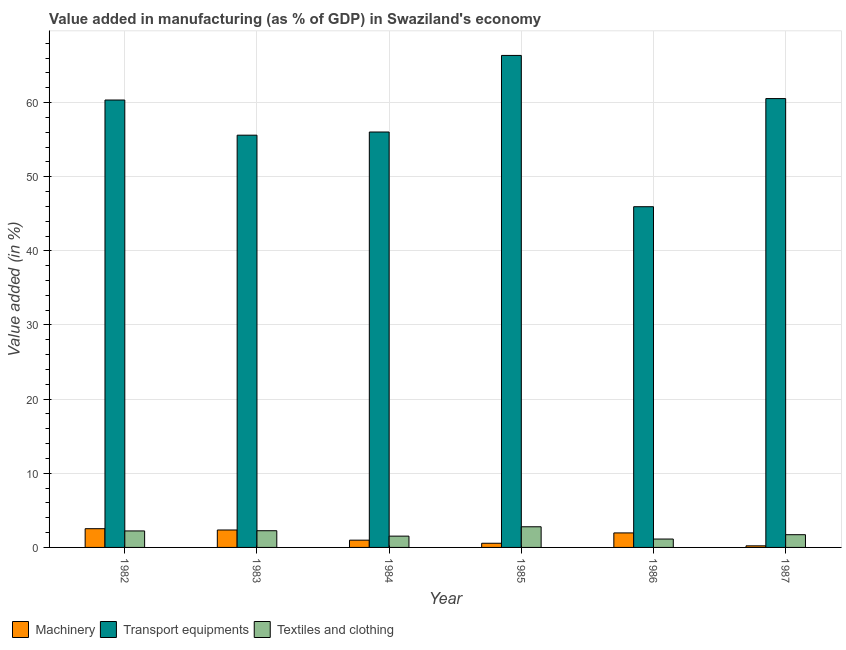How many different coloured bars are there?
Your response must be concise. 3. Are the number of bars on each tick of the X-axis equal?
Your response must be concise. Yes. How many bars are there on the 6th tick from the right?
Your answer should be very brief. 3. In how many cases, is the number of bars for a given year not equal to the number of legend labels?
Offer a very short reply. 0. What is the value added in manufacturing machinery in 1984?
Your answer should be very brief. 0.98. Across all years, what is the maximum value added in manufacturing transport equipments?
Your answer should be very brief. 66.36. Across all years, what is the minimum value added in manufacturing textile and clothing?
Provide a succinct answer. 1.13. In which year was the value added in manufacturing transport equipments maximum?
Provide a short and direct response. 1985. In which year was the value added in manufacturing transport equipments minimum?
Your response must be concise. 1986. What is the total value added in manufacturing transport equipments in the graph?
Your response must be concise. 344.82. What is the difference between the value added in manufacturing textile and clothing in 1983 and that in 1985?
Provide a succinct answer. -0.53. What is the difference between the value added in manufacturing textile and clothing in 1982 and the value added in manufacturing machinery in 1983?
Keep it short and to the point. -0.03. What is the average value added in manufacturing textile and clothing per year?
Offer a very short reply. 1.94. In the year 1984, what is the difference between the value added in manufacturing machinery and value added in manufacturing textile and clothing?
Give a very brief answer. 0. What is the ratio of the value added in manufacturing machinery in 1985 to that in 1987?
Make the answer very short. 2.62. Is the value added in manufacturing machinery in 1982 less than that in 1984?
Provide a short and direct response. No. What is the difference between the highest and the second highest value added in manufacturing textile and clothing?
Ensure brevity in your answer.  0.53. What is the difference between the highest and the lowest value added in manufacturing textile and clothing?
Provide a short and direct response. 1.65. In how many years, is the value added in manufacturing textile and clothing greater than the average value added in manufacturing textile and clothing taken over all years?
Your answer should be very brief. 3. Is the sum of the value added in manufacturing transport equipments in 1982 and 1984 greater than the maximum value added in manufacturing textile and clothing across all years?
Give a very brief answer. Yes. What does the 1st bar from the left in 1985 represents?
Provide a succinct answer. Machinery. What does the 3rd bar from the right in 1985 represents?
Your answer should be very brief. Machinery. Is it the case that in every year, the sum of the value added in manufacturing machinery and value added in manufacturing transport equipments is greater than the value added in manufacturing textile and clothing?
Make the answer very short. Yes. Are all the bars in the graph horizontal?
Make the answer very short. No. Where does the legend appear in the graph?
Provide a short and direct response. Bottom left. How many legend labels are there?
Your answer should be compact. 3. What is the title of the graph?
Your answer should be very brief. Value added in manufacturing (as % of GDP) in Swaziland's economy. What is the label or title of the X-axis?
Your response must be concise. Year. What is the label or title of the Y-axis?
Provide a succinct answer. Value added (in %). What is the Value added (in %) of Machinery in 1982?
Make the answer very short. 2.53. What is the Value added (in %) in Transport equipments in 1982?
Keep it short and to the point. 60.34. What is the Value added (in %) in Textiles and clothing in 1982?
Provide a succinct answer. 2.23. What is the Value added (in %) in Machinery in 1983?
Offer a terse response. 2.35. What is the Value added (in %) of Transport equipments in 1983?
Provide a succinct answer. 55.6. What is the Value added (in %) of Textiles and clothing in 1983?
Your answer should be compact. 2.25. What is the Value added (in %) in Machinery in 1984?
Your answer should be very brief. 0.98. What is the Value added (in %) in Transport equipments in 1984?
Provide a succinct answer. 56.03. What is the Value added (in %) in Textiles and clothing in 1984?
Your response must be concise. 1.52. What is the Value added (in %) in Machinery in 1985?
Provide a short and direct response. 0.56. What is the Value added (in %) in Transport equipments in 1985?
Give a very brief answer. 66.36. What is the Value added (in %) of Textiles and clothing in 1985?
Give a very brief answer. 2.79. What is the Value added (in %) of Machinery in 1986?
Your answer should be very brief. 1.96. What is the Value added (in %) in Transport equipments in 1986?
Offer a terse response. 45.95. What is the Value added (in %) in Textiles and clothing in 1986?
Offer a very short reply. 1.13. What is the Value added (in %) in Machinery in 1987?
Your answer should be compact. 0.22. What is the Value added (in %) in Transport equipments in 1987?
Your response must be concise. 60.54. What is the Value added (in %) in Textiles and clothing in 1987?
Give a very brief answer. 1.72. Across all years, what is the maximum Value added (in %) in Machinery?
Give a very brief answer. 2.53. Across all years, what is the maximum Value added (in %) in Transport equipments?
Ensure brevity in your answer.  66.36. Across all years, what is the maximum Value added (in %) of Textiles and clothing?
Your answer should be very brief. 2.79. Across all years, what is the minimum Value added (in %) of Machinery?
Your response must be concise. 0.22. Across all years, what is the minimum Value added (in %) in Transport equipments?
Your answer should be very brief. 45.95. Across all years, what is the minimum Value added (in %) in Textiles and clothing?
Keep it short and to the point. 1.13. What is the total Value added (in %) in Machinery in the graph?
Your response must be concise. 8.59. What is the total Value added (in %) in Transport equipments in the graph?
Your answer should be compact. 344.82. What is the total Value added (in %) of Textiles and clothing in the graph?
Keep it short and to the point. 11.64. What is the difference between the Value added (in %) of Machinery in 1982 and that in 1983?
Ensure brevity in your answer.  0.17. What is the difference between the Value added (in %) in Transport equipments in 1982 and that in 1983?
Make the answer very short. 4.74. What is the difference between the Value added (in %) in Textiles and clothing in 1982 and that in 1983?
Keep it short and to the point. -0.03. What is the difference between the Value added (in %) in Machinery in 1982 and that in 1984?
Your response must be concise. 1.55. What is the difference between the Value added (in %) of Transport equipments in 1982 and that in 1984?
Your answer should be very brief. 4.31. What is the difference between the Value added (in %) in Textiles and clothing in 1982 and that in 1984?
Your answer should be compact. 0.7. What is the difference between the Value added (in %) of Machinery in 1982 and that in 1985?
Provide a short and direct response. 1.96. What is the difference between the Value added (in %) in Transport equipments in 1982 and that in 1985?
Ensure brevity in your answer.  -6.01. What is the difference between the Value added (in %) of Textiles and clothing in 1982 and that in 1985?
Provide a succinct answer. -0.56. What is the difference between the Value added (in %) in Machinery in 1982 and that in 1986?
Keep it short and to the point. 0.57. What is the difference between the Value added (in %) in Transport equipments in 1982 and that in 1986?
Offer a very short reply. 14.39. What is the difference between the Value added (in %) of Textiles and clothing in 1982 and that in 1986?
Your answer should be compact. 1.09. What is the difference between the Value added (in %) in Machinery in 1982 and that in 1987?
Your answer should be compact. 2.31. What is the difference between the Value added (in %) in Transport equipments in 1982 and that in 1987?
Offer a terse response. -0.19. What is the difference between the Value added (in %) in Textiles and clothing in 1982 and that in 1987?
Offer a terse response. 0.51. What is the difference between the Value added (in %) of Machinery in 1983 and that in 1984?
Offer a very short reply. 1.37. What is the difference between the Value added (in %) in Transport equipments in 1983 and that in 1984?
Ensure brevity in your answer.  -0.43. What is the difference between the Value added (in %) of Textiles and clothing in 1983 and that in 1984?
Offer a very short reply. 0.73. What is the difference between the Value added (in %) of Machinery in 1983 and that in 1985?
Provide a succinct answer. 1.79. What is the difference between the Value added (in %) in Transport equipments in 1983 and that in 1985?
Your answer should be compact. -10.76. What is the difference between the Value added (in %) in Textiles and clothing in 1983 and that in 1985?
Provide a short and direct response. -0.53. What is the difference between the Value added (in %) of Machinery in 1983 and that in 1986?
Give a very brief answer. 0.39. What is the difference between the Value added (in %) in Transport equipments in 1983 and that in 1986?
Your response must be concise. 9.65. What is the difference between the Value added (in %) in Textiles and clothing in 1983 and that in 1986?
Offer a very short reply. 1.12. What is the difference between the Value added (in %) in Machinery in 1983 and that in 1987?
Provide a succinct answer. 2.14. What is the difference between the Value added (in %) in Transport equipments in 1983 and that in 1987?
Provide a short and direct response. -4.94. What is the difference between the Value added (in %) of Textiles and clothing in 1983 and that in 1987?
Provide a short and direct response. 0.54. What is the difference between the Value added (in %) of Machinery in 1984 and that in 1985?
Your response must be concise. 0.42. What is the difference between the Value added (in %) of Transport equipments in 1984 and that in 1985?
Your response must be concise. -10.33. What is the difference between the Value added (in %) of Textiles and clothing in 1984 and that in 1985?
Offer a terse response. -1.26. What is the difference between the Value added (in %) of Machinery in 1984 and that in 1986?
Your response must be concise. -0.98. What is the difference between the Value added (in %) of Transport equipments in 1984 and that in 1986?
Your response must be concise. 10.07. What is the difference between the Value added (in %) in Textiles and clothing in 1984 and that in 1986?
Your answer should be very brief. 0.39. What is the difference between the Value added (in %) in Machinery in 1984 and that in 1987?
Offer a very short reply. 0.76. What is the difference between the Value added (in %) in Transport equipments in 1984 and that in 1987?
Provide a short and direct response. -4.51. What is the difference between the Value added (in %) in Textiles and clothing in 1984 and that in 1987?
Your answer should be compact. -0.19. What is the difference between the Value added (in %) of Machinery in 1985 and that in 1986?
Offer a very short reply. -1.39. What is the difference between the Value added (in %) of Transport equipments in 1985 and that in 1986?
Provide a succinct answer. 20.4. What is the difference between the Value added (in %) in Textiles and clothing in 1985 and that in 1986?
Ensure brevity in your answer.  1.65. What is the difference between the Value added (in %) in Machinery in 1985 and that in 1987?
Your response must be concise. 0.35. What is the difference between the Value added (in %) in Transport equipments in 1985 and that in 1987?
Your answer should be very brief. 5.82. What is the difference between the Value added (in %) of Textiles and clothing in 1985 and that in 1987?
Your answer should be compact. 1.07. What is the difference between the Value added (in %) in Machinery in 1986 and that in 1987?
Provide a succinct answer. 1.74. What is the difference between the Value added (in %) in Transport equipments in 1986 and that in 1987?
Your answer should be compact. -14.58. What is the difference between the Value added (in %) of Textiles and clothing in 1986 and that in 1987?
Provide a succinct answer. -0.58. What is the difference between the Value added (in %) of Machinery in 1982 and the Value added (in %) of Transport equipments in 1983?
Provide a short and direct response. -53.07. What is the difference between the Value added (in %) in Machinery in 1982 and the Value added (in %) in Textiles and clothing in 1983?
Your answer should be compact. 0.27. What is the difference between the Value added (in %) of Transport equipments in 1982 and the Value added (in %) of Textiles and clothing in 1983?
Offer a terse response. 58.09. What is the difference between the Value added (in %) in Machinery in 1982 and the Value added (in %) in Transport equipments in 1984?
Offer a terse response. -53.5. What is the difference between the Value added (in %) in Machinery in 1982 and the Value added (in %) in Textiles and clothing in 1984?
Offer a terse response. 1. What is the difference between the Value added (in %) of Transport equipments in 1982 and the Value added (in %) of Textiles and clothing in 1984?
Your answer should be very brief. 58.82. What is the difference between the Value added (in %) of Machinery in 1982 and the Value added (in %) of Transport equipments in 1985?
Your answer should be very brief. -63.83. What is the difference between the Value added (in %) in Machinery in 1982 and the Value added (in %) in Textiles and clothing in 1985?
Offer a very short reply. -0.26. What is the difference between the Value added (in %) of Transport equipments in 1982 and the Value added (in %) of Textiles and clothing in 1985?
Make the answer very short. 57.56. What is the difference between the Value added (in %) of Machinery in 1982 and the Value added (in %) of Transport equipments in 1986?
Offer a very short reply. -43.43. What is the difference between the Value added (in %) of Machinery in 1982 and the Value added (in %) of Textiles and clothing in 1986?
Ensure brevity in your answer.  1.39. What is the difference between the Value added (in %) in Transport equipments in 1982 and the Value added (in %) in Textiles and clothing in 1986?
Provide a short and direct response. 59.21. What is the difference between the Value added (in %) of Machinery in 1982 and the Value added (in %) of Transport equipments in 1987?
Provide a succinct answer. -58.01. What is the difference between the Value added (in %) in Machinery in 1982 and the Value added (in %) in Textiles and clothing in 1987?
Offer a terse response. 0.81. What is the difference between the Value added (in %) in Transport equipments in 1982 and the Value added (in %) in Textiles and clothing in 1987?
Your response must be concise. 58.63. What is the difference between the Value added (in %) in Machinery in 1983 and the Value added (in %) in Transport equipments in 1984?
Provide a short and direct response. -53.68. What is the difference between the Value added (in %) in Machinery in 1983 and the Value added (in %) in Textiles and clothing in 1984?
Ensure brevity in your answer.  0.83. What is the difference between the Value added (in %) of Transport equipments in 1983 and the Value added (in %) of Textiles and clothing in 1984?
Your answer should be compact. 54.08. What is the difference between the Value added (in %) of Machinery in 1983 and the Value added (in %) of Transport equipments in 1985?
Offer a very short reply. -64.01. What is the difference between the Value added (in %) in Machinery in 1983 and the Value added (in %) in Textiles and clothing in 1985?
Your answer should be very brief. -0.43. What is the difference between the Value added (in %) in Transport equipments in 1983 and the Value added (in %) in Textiles and clothing in 1985?
Offer a very short reply. 52.81. What is the difference between the Value added (in %) of Machinery in 1983 and the Value added (in %) of Transport equipments in 1986?
Make the answer very short. -43.6. What is the difference between the Value added (in %) of Machinery in 1983 and the Value added (in %) of Textiles and clothing in 1986?
Ensure brevity in your answer.  1.22. What is the difference between the Value added (in %) of Transport equipments in 1983 and the Value added (in %) of Textiles and clothing in 1986?
Your answer should be compact. 54.47. What is the difference between the Value added (in %) of Machinery in 1983 and the Value added (in %) of Transport equipments in 1987?
Ensure brevity in your answer.  -58.19. What is the difference between the Value added (in %) of Machinery in 1983 and the Value added (in %) of Textiles and clothing in 1987?
Make the answer very short. 0.63. What is the difference between the Value added (in %) of Transport equipments in 1983 and the Value added (in %) of Textiles and clothing in 1987?
Give a very brief answer. 53.88. What is the difference between the Value added (in %) in Machinery in 1984 and the Value added (in %) in Transport equipments in 1985?
Keep it short and to the point. -65.38. What is the difference between the Value added (in %) of Machinery in 1984 and the Value added (in %) of Textiles and clothing in 1985?
Offer a terse response. -1.81. What is the difference between the Value added (in %) in Transport equipments in 1984 and the Value added (in %) in Textiles and clothing in 1985?
Keep it short and to the point. 53.24. What is the difference between the Value added (in %) in Machinery in 1984 and the Value added (in %) in Transport equipments in 1986?
Give a very brief answer. -44.97. What is the difference between the Value added (in %) of Machinery in 1984 and the Value added (in %) of Textiles and clothing in 1986?
Keep it short and to the point. -0.15. What is the difference between the Value added (in %) of Transport equipments in 1984 and the Value added (in %) of Textiles and clothing in 1986?
Your response must be concise. 54.9. What is the difference between the Value added (in %) of Machinery in 1984 and the Value added (in %) of Transport equipments in 1987?
Offer a very short reply. -59.56. What is the difference between the Value added (in %) in Machinery in 1984 and the Value added (in %) in Textiles and clothing in 1987?
Your answer should be compact. -0.74. What is the difference between the Value added (in %) in Transport equipments in 1984 and the Value added (in %) in Textiles and clothing in 1987?
Keep it short and to the point. 54.31. What is the difference between the Value added (in %) of Machinery in 1985 and the Value added (in %) of Transport equipments in 1986?
Ensure brevity in your answer.  -45.39. What is the difference between the Value added (in %) in Machinery in 1985 and the Value added (in %) in Textiles and clothing in 1986?
Give a very brief answer. -0.57. What is the difference between the Value added (in %) in Transport equipments in 1985 and the Value added (in %) in Textiles and clothing in 1986?
Offer a terse response. 65.23. What is the difference between the Value added (in %) of Machinery in 1985 and the Value added (in %) of Transport equipments in 1987?
Offer a terse response. -59.97. What is the difference between the Value added (in %) in Machinery in 1985 and the Value added (in %) in Textiles and clothing in 1987?
Your answer should be very brief. -1.15. What is the difference between the Value added (in %) in Transport equipments in 1985 and the Value added (in %) in Textiles and clothing in 1987?
Offer a terse response. 64.64. What is the difference between the Value added (in %) in Machinery in 1986 and the Value added (in %) in Transport equipments in 1987?
Offer a terse response. -58.58. What is the difference between the Value added (in %) in Machinery in 1986 and the Value added (in %) in Textiles and clothing in 1987?
Your response must be concise. 0.24. What is the difference between the Value added (in %) in Transport equipments in 1986 and the Value added (in %) in Textiles and clothing in 1987?
Keep it short and to the point. 44.24. What is the average Value added (in %) of Machinery per year?
Your response must be concise. 1.43. What is the average Value added (in %) in Transport equipments per year?
Provide a short and direct response. 57.47. What is the average Value added (in %) of Textiles and clothing per year?
Your answer should be very brief. 1.94. In the year 1982, what is the difference between the Value added (in %) of Machinery and Value added (in %) of Transport equipments?
Ensure brevity in your answer.  -57.82. In the year 1982, what is the difference between the Value added (in %) in Transport equipments and Value added (in %) in Textiles and clothing?
Your response must be concise. 58.12. In the year 1983, what is the difference between the Value added (in %) of Machinery and Value added (in %) of Transport equipments?
Give a very brief answer. -53.25. In the year 1983, what is the difference between the Value added (in %) of Machinery and Value added (in %) of Textiles and clothing?
Your response must be concise. 0.1. In the year 1983, what is the difference between the Value added (in %) of Transport equipments and Value added (in %) of Textiles and clothing?
Offer a very short reply. 53.35. In the year 1984, what is the difference between the Value added (in %) of Machinery and Value added (in %) of Transport equipments?
Keep it short and to the point. -55.05. In the year 1984, what is the difference between the Value added (in %) in Machinery and Value added (in %) in Textiles and clothing?
Offer a very short reply. -0.54. In the year 1984, what is the difference between the Value added (in %) of Transport equipments and Value added (in %) of Textiles and clothing?
Provide a short and direct response. 54.5. In the year 1985, what is the difference between the Value added (in %) of Machinery and Value added (in %) of Transport equipments?
Give a very brief answer. -65.79. In the year 1985, what is the difference between the Value added (in %) of Machinery and Value added (in %) of Textiles and clothing?
Give a very brief answer. -2.22. In the year 1985, what is the difference between the Value added (in %) of Transport equipments and Value added (in %) of Textiles and clothing?
Offer a very short reply. 63.57. In the year 1986, what is the difference between the Value added (in %) of Machinery and Value added (in %) of Transport equipments?
Your answer should be compact. -44. In the year 1986, what is the difference between the Value added (in %) of Machinery and Value added (in %) of Textiles and clothing?
Your answer should be very brief. 0.82. In the year 1986, what is the difference between the Value added (in %) in Transport equipments and Value added (in %) in Textiles and clothing?
Provide a succinct answer. 44.82. In the year 1987, what is the difference between the Value added (in %) in Machinery and Value added (in %) in Transport equipments?
Keep it short and to the point. -60.32. In the year 1987, what is the difference between the Value added (in %) in Machinery and Value added (in %) in Textiles and clothing?
Ensure brevity in your answer.  -1.5. In the year 1987, what is the difference between the Value added (in %) of Transport equipments and Value added (in %) of Textiles and clothing?
Provide a short and direct response. 58.82. What is the ratio of the Value added (in %) in Machinery in 1982 to that in 1983?
Keep it short and to the point. 1.07. What is the ratio of the Value added (in %) in Transport equipments in 1982 to that in 1983?
Keep it short and to the point. 1.09. What is the ratio of the Value added (in %) in Textiles and clothing in 1982 to that in 1983?
Provide a succinct answer. 0.99. What is the ratio of the Value added (in %) of Machinery in 1982 to that in 1984?
Ensure brevity in your answer.  2.58. What is the ratio of the Value added (in %) of Transport equipments in 1982 to that in 1984?
Offer a very short reply. 1.08. What is the ratio of the Value added (in %) in Textiles and clothing in 1982 to that in 1984?
Your response must be concise. 1.46. What is the ratio of the Value added (in %) in Machinery in 1982 to that in 1985?
Provide a succinct answer. 4.48. What is the ratio of the Value added (in %) in Transport equipments in 1982 to that in 1985?
Your answer should be compact. 0.91. What is the ratio of the Value added (in %) of Textiles and clothing in 1982 to that in 1985?
Ensure brevity in your answer.  0.8. What is the ratio of the Value added (in %) of Machinery in 1982 to that in 1986?
Your response must be concise. 1.29. What is the ratio of the Value added (in %) in Transport equipments in 1982 to that in 1986?
Offer a terse response. 1.31. What is the ratio of the Value added (in %) of Textiles and clothing in 1982 to that in 1986?
Offer a very short reply. 1.97. What is the ratio of the Value added (in %) in Machinery in 1982 to that in 1987?
Offer a terse response. 11.74. What is the ratio of the Value added (in %) in Transport equipments in 1982 to that in 1987?
Your answer should be very brief. 1. What is the ratio of the Value added (in %) in Textiles and clothing in 1982 to that in 1987?
Give a very brief answer. 1.3. What is the ratio of the Value added (in %) in Machinery in 1983 to that in 1984?
Make the answer very short. 2.4. What is the ratio of the Value added (in %) in Textiles and clothing in 1983 to that in 1984?
Offer a very short reply. 1.48. What is the ratio of the Value added (in %) of Machinery in 1983 to that in 1985?
Make the answer very short. 4.17. What is the ratio of the Value added (in %) of Transport equipments in 1983 to that in 1985?
Your response must be concise. 0.84. What is the ratio of the Value added (in %) in Textiles and clothing in 1983 to that in 1985?
Offer a very short reply. 0.81. What is the ratio of the Value added (in %) of Machinery in 1983 to that in 1986?
Offer a terse response. 1.2. What is the ratio of the Value added (in %) of Transport equipments in 1983 to that in 1986?
Your answer should be very brief. 1.21. What is the ratio of the Value added (in %) in Textiles and clothing in 1983 to that in 1986?
Provide a short and direct response. 1.99. What is the ratio of the Value added (in %) of Machinery in 1983 to that in 1987?
Your answer should be compact. 10.93. What is the ratio of the Value added (in %) of Transport equipments in 1983 to that in 1987?
Provide a succinct answer. 0.92. What is the ratio of the Value added (in %) in Textiles and clothing in 1983 to that in 1987?
Give a very brief answer. 1.31. What is the ratio of the Value added (in %) in Machinery in 1984 to that in 1985?
Offer a terse response. 1.74. What is the ratio of the Value added (in %) in Transport equipments in 1984 to that in 1985?
Give a very brief answer. 0.84. What is the ratio of the Value added (in %) in Textiles and clothing in 1984 to that in 1985?
Keep it short and to the point. 0.55. What is the ratio of the Value added (in %) of Machinery in 1984 to that in 1986?
Offer a very short reply. 0.5. What is the ratio of the Value added (in %) in Transport equipments in 1984 to that in 1986?
Your answer should be compact. 1.22. What is the ratio of the Value added (in %) of Textiles and clothing in 1984 to that in 1986?
Ensure brevity in your answer.  1.35. What is the ratio of the Value added (in %) of Machinery in 1984 to that in 1987?
Offer a very short reply. 4.55. What is the ratio of the Value added (in %) in Transport equipments in 1984 to that in 1987?
Keep it short and to the point. 0.93. What is the ratio of the Value added (in %) of Textiles and clothing in 1984 to that in 1987?
Provide a succinct answer. 0.89. What is the ratio of the Value added (in %) of Machinery in 1985 to that in 1986?
Make the answer very short. 0.29. What is the ratio of the Value added (in %) of Transport equipments in 1985 to that in 1986?
Your answer should be compact. 1.44. What is the ratio of the Value added (in %) in Textiles and clothing in 1985 to that in 1986?
Make the answer very short. 2.46. What is the ratio of the Value added (in %) of Machinery in 1985 to that in 1987?
Give a very brief answer. 2.62. What is the ratio of the Value added (in %) in Transport equipments in 1985 to that in 1987?
Your answer should be very brief. 1.1. What is the ratio of the Value added (in %) in Textiles and clothing in 1985 to that in 1987?
Provide a succinct answer. 1.62. What is the ratio of the Value added (in %) of Machinery in 1986 to that in 1987?
Offer a terse response. 9.09. What is the ratio of the Value added (in %) in Transport equipments in 1986 to that in 1987?
Your answer should be compact. 0.76. What is the ratio of the Value added (in %) in Textiles and clothing in 1986 to that in 1987?
Offer a very short reply. 0.66. What is the difference between the highest and the second highest Value added (in %) in Machinery?
Provide a succinct answer. 0.17. What is the difference between the highest and the second highest Value added (in %) in Transport equipments?
Provide a short and direct response. 5.82. What is the difference between the highest and the second highest Value added (in %) in Textiles and clothing?
Ensure brevity in your answer.  0.53. What is the difference between the highest and the lowest Value added (in %) of Machinery?
Your answer should be compact. 2.31. What is the difference between the highest and the lowest Value added (in %) of Transport equipments?
Your answer should be very brief. 20.4. What is the difference between the highest and the lowest Value added (in %) of Textiles and clothing?
Your response must be concise. 1.65. 